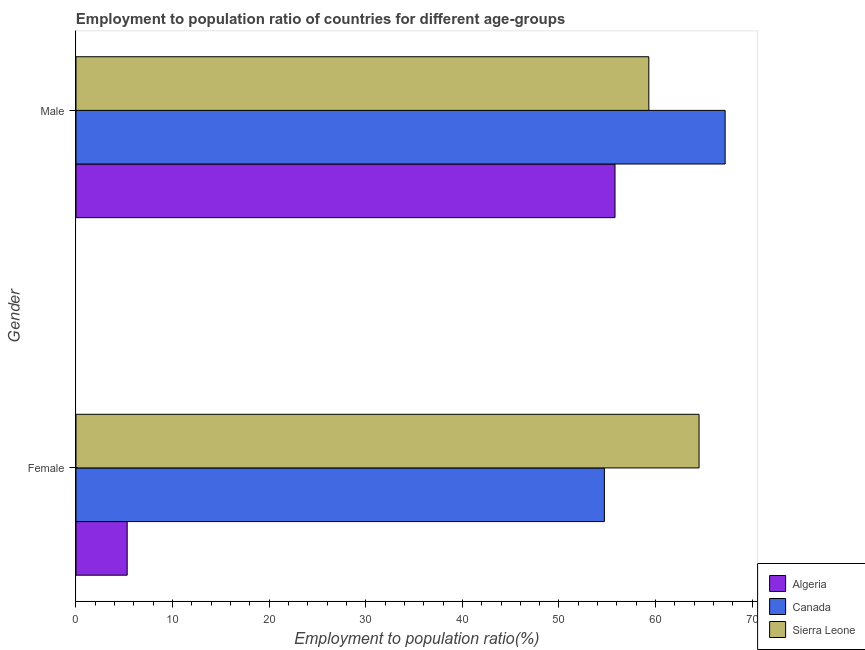How many different coloured bars are there?
Give a very brief answer. 3. How many bars are there on the 2nd tick from the top?
Offer a terse response. 3. How many bars are there on the 1st tick from the bottom?
Offer a terse response. 3. What is the label of the 2nd group of bars from the top?
Provide a short and direct response. Female. What is the employment to population ratio(male) in Canada?
Offer a terse response. 67.2. Across all countries, what is the maximum employment to population ratio(female)?
Make the answer very short. 64.5. Across all countries, what is the minimum employment to population ratio(female)?
Give a very brief answer. 5.3. In which country was the employment to population ratio(male) minimum?
Offer a terse response. Algeria. What is the total employment to population ratio(male) in the graph?
Give a very brief answer. 182.3. What is the difference between the employment to population ratio(male) in Sierra Leone and that in Algeria?
Give a very brief answer. 3.5. What is the difference between the employment to population ratio(male) in Algeria and the employment to population ratio(female) in Sierra Leone?
Give a very brief answer. -8.7. What is the average employment to population ratio(male) per country?
Provide a succinct answer. 60.77. What is the difference between the employment to population ratio(male) and employment to population ratio(female) in Sierra Leone?
Keep it short and to the point. -5.2. What is the ratio of the employment to population ratio(female) in Canada to that in Algeria?
Make the answer very short. 10.32. Is the employment to population ratio(female) in Canada less than that in Sierra Leone?
Offer a very short reply. Yes. What does the 2nd bar from the top in Female represents?
Your response must be concise. Canada. What does the 3rd bar from the bottom in Male represents?
Offer a terse response. Sierra Leone. What is the difference between two consecutive major ticks on the X-axis?
Ensure brevity in your answer.  10. Are the values on the major ticks of X-axis written in scientific E-notation?
Your answer should be compact. No. Does the graph contain grids?
Your answer should be compact. No. How many legend labels are there?
Your answer should be compact. 3. How are the legend labels stacked?
Your answer should be compact. Vertical. What is the title of the graph?
Ensure brevity in your answer.  Employment to population ratio of countries for different age-groups. Does "Madagascar" appear as one of the legend labels in the graph?
Your answer should be compact. No. What is the label or title of the X-axis?
Your response must be concise. Employment to population ratio(%). What is the Employment to population ratio(%) of Algeria in Female?
Your answer should be very brief. 5.3. What is the Employment to population ratio(%) in Canada in Female?
Offer a terse response. 54.7. What is the Employment to population ratio(%) in Sierra Leone in Female?
Keep it short and to the point. 64.5. What is the Employment to population ratio(%) of Algeria in Male?
Ensure brevity in your answer.  55.8. What is the Employment to population ratio(%) in Canada in Male?
Provide a succinct answer. 67.2. What is the Employment to population ratio(%) in Sierra Leone in Male?
Offer a terse response. 59.3. Across all Gender, what is the maximum Employment to population ratio(%) of Algeria?
Your answer should be compact. 55.8. Across all Gender, what is the maximum Employment to population ratio(%) in Canada?
Give a very brief answer. 67.2. Across all Gender, what is the maximum Employment to population ratio(%) of Sierra Leone?
Give a very brief answer. 64.5. Across all Gender, what is the minimum Employment to population ratio(%) in Algeria?
Ensure brevity in your answer.  5.3. Across all Gender, what is the minimum Employment to population ratio(%) of Canada?
Give a very brief answer. 54.7. Across all Gender, what is the minimum Employment to population ratio(%) of Sierra Leone?
Provide a short and direct response. 59.3. What is the total Employment to population ratio(%) in Algeria in the graph?
Your response must be concise. 61.1. What is the total Employment to population ratio(%) in Canada in the graph?
Keep it short and to the point. 121.9. What is the total Employment to population ratio(%) in Sierra Leone in the graph?
Your answer should be compact. 123.8. What is the difference between the Employment to population ratio(%) of Algeria in Female and that in Male?
Offer a terse response. -50.5. What is the difference between the Employment to population ratio(%) of Canada in Female and that in Male?
Provide a short and direct response. -12.5. What is the difference between the Employment to population ratio(%) in Sierra Leone in Female and that in Male?
Provide a succinct answer. 5.2. What is the difference between the Employment to population ratio(%) of Algeria in Female and the Employment to population ratio(%) of Canada in Male?
Offer a terse response. -61.9. What is the difference between the Employment to population ratio(%) in Algeria in Female and the Employment to population ratio(%) in Sierra Leone in Male?
Give a very brief answer. -54. What is the difference between the Employment to population ratio(%) of Canada in Female and the Employment to population ratio(%) of Sierra Leone in Male?
Give a very brief answer. -4.6. What is the average Employment to population ratio(%) of Algeria per Gender?
Ensure brevity in your answer.  30.55. What is the average Employment to population ratio(%) in Canada per Gender?
Your answer should be very brief. 60.95. What is the average Employment to population ratio(%) in Sierra Leone per Gender?
Provide a succinct answer. 61.9. What is the difference between the Employment to population ratio(%) of Algeria and Employment to population ratio(%) of Canada in Female?
Offer a terse response. -49.4. What is the difference between the Employment to population ratio(%) in Algeria and Employment to population ratio(%) in Sierra Leone in Female?
Your answer should be compact. -59.2. What is the difference between the Employment to population ratio(%) in Canada and Employment to population ratio(%) in Sierra Leone in Female?
Your response must be concise. -9.8. What is the difference between the Employment to population ratio(%) of Algeria and Employment to population ratio(%) of Canada in Male?
Offer a very short reply. -11.4. What is the difference between the Employment to population ratio(%) of Algeria and Employment to population ratio(%) of Sierra Leone in Male?
Provide a succinct answer. -3.5. What is the ratio of the Employment to population ratio(%) of Algeria in Female to that in Male?
Make the answer very short. 0.1. What is the ratio of the Employment to population ratio(%) in Canada in Female to that in Male?
Give a very brief answer. 0.81. What is the ratio of the Employment to population ratio(%) of Sierra Leone in Female to that in Male?
Your response must be concise. 1.09. What is the difference between the highest and the second highest Employment to population ratio(%) in Algeria?
Provide a succinct answer. 50.5. What is the difference between the highest and the lowest Employment to population ratio(%) of Algeria?
Offer a very short reply. 50.5. 